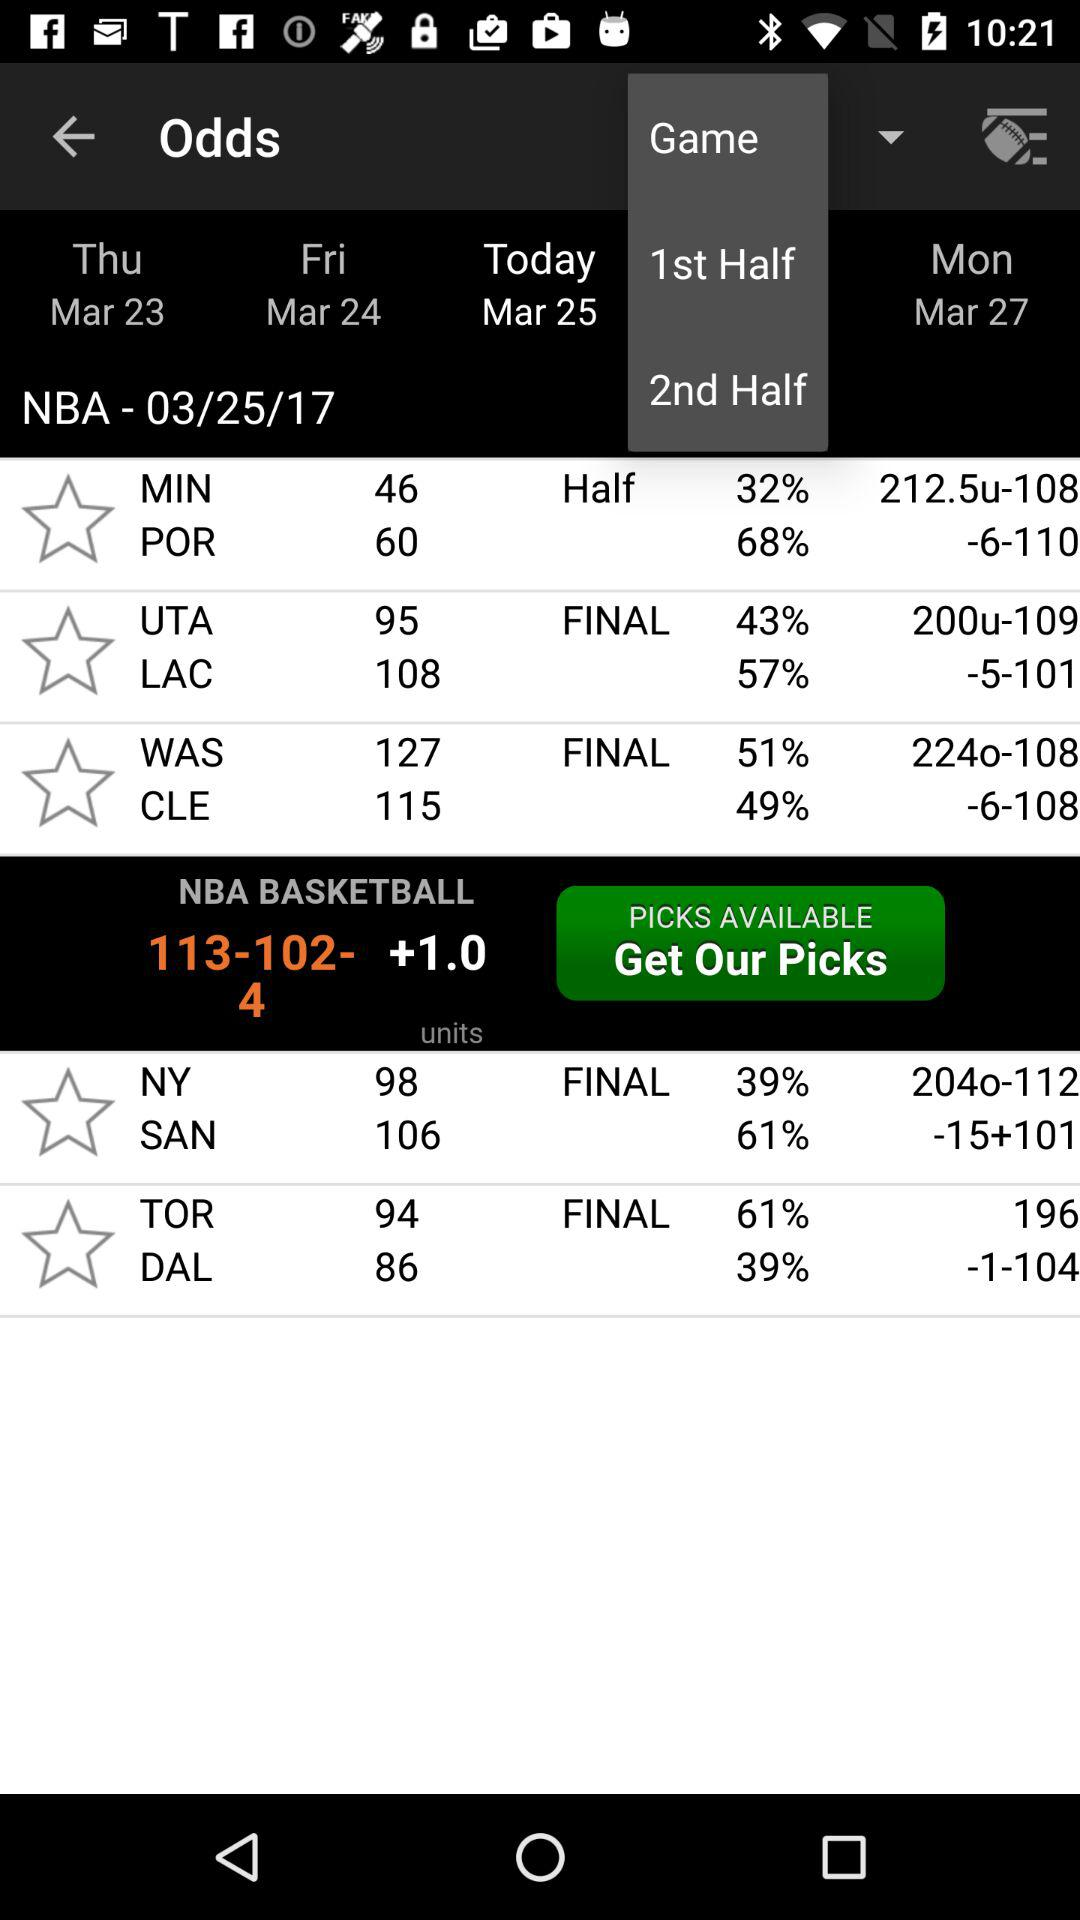What is the final score of NY vs. SAN? The final scores of NY vs. SAN are 98 and 106, respectively. 